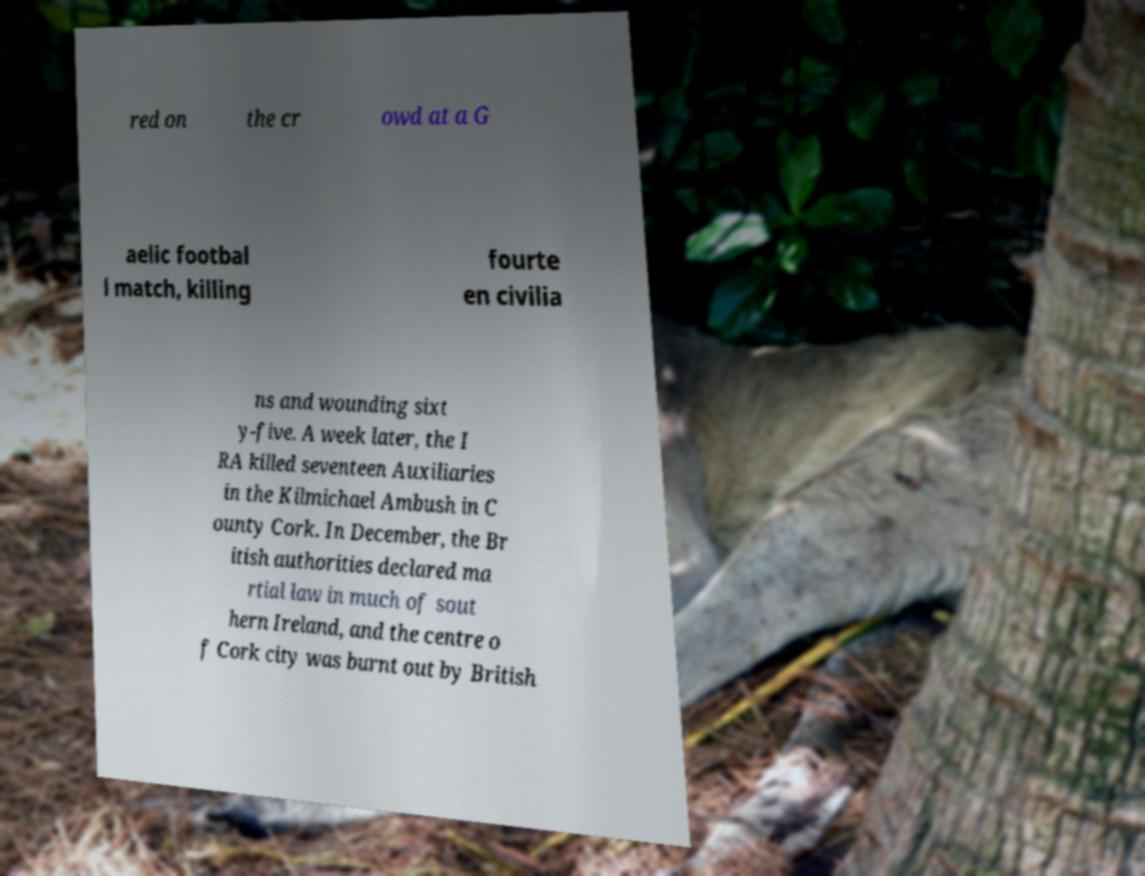What messages or text are displayed in this image? I need them in a readable, typed format. red on the cr owd at a G aelic footbal l match, killing fourte en civilia ns and wounding sixt y-five. A week later, the I RA killed seventeen Auxiliaries in the Kilmichael Ambush in C ounty Cork. In December, the Br itish authorities declared ma rtial law in much of sout hern Ireland, and the centre o f Cork city was burnt out by British 